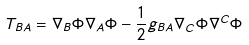Convert formula to latex. <formula><loc_0><loc_0><loc_500><loc_500>T _ { B A } = \nabla _ { B } \Phi \nabla _ { A } \Phi - \frac { 1 } { 2 } g _ { B A } \nabla _ { C } \Phi \nabla ^ { C } \Phi</formula> 